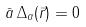<formula> <loc_0><loc_0><loc_500><loc_500>\bar { a } \, \Delta _ { \alpha } ( \vec { r } ) = 0</formula> 